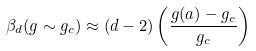Convert formula to latex. <formula><loc_0><loc_0><loc_500><loc_500>\beta _ { d } ( g \sim g _ { c } ) \approx ( d - 2 ) \left ( \frac { g ( a ) - g _ { c } } { g _ { c } } \right )</formula> 